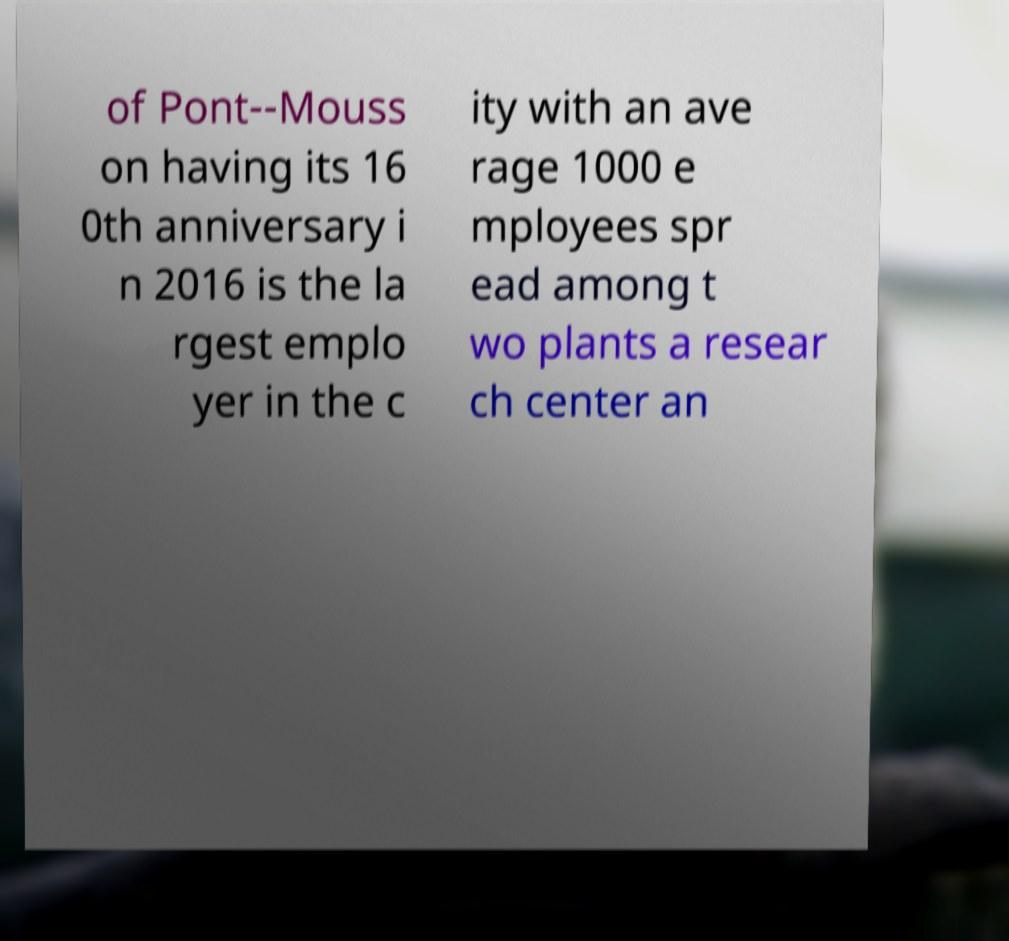Could you extract and type out the text from this image? of Pont--Mouss on having its 16 0th anniversary i n 2016 is the la rgest emplo yer in the c ity with an ave rage 1000 e mployees spr ead among t wo plants a resear ch center an 